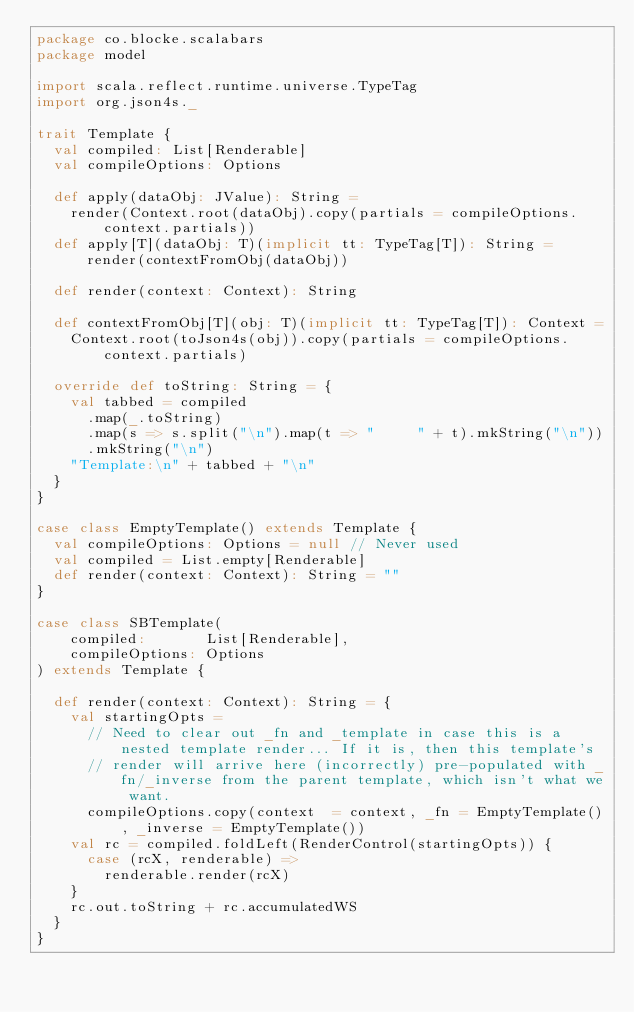<code> <loc_0><loc_0><loc_500><loc_500><_Scala_>package co.blocke.scalabars
package model

import scala.reflect.runtime.universe.TypeTag
import org.json4s._

trait Template {
  val compiled: List[Renderable]
  val compileOptions: Options

  def apply(dataObj: JValue): String =
    render(Context.root(dataObj).copy(partials = compileOptions.context.partials))
  def apply[T](dataObj: T)(implicit tt: TypeTag[T]): String = render(contextFromObj(dataObj))

  def render(context: Context): String

  def contextFromObj[T](obj: T)(implicit tt: TypeTag[T]): Context =
    Context.root(toJson4s(obj)).copy(partials = compileOptions.context.partials)

  override def toString: String = {
    val tabbed = compiled
      .map(_.toString)
      .map(s => s.split("\n").map(t => "     " + t).mkString("\n"))
      .mkString("\n")
    "Template:\n" + tabbed + "\n"
  }
}

case class EmptyTemplate() extends Template {
  val compileOptions: Options = null // Never used
  val compiled = List.empty[Renderable]
  def render(context: Context): String = ""
}

case class SBTemplate(
    compiled:       List[Renderable],
    compileOptions: Options
) extends Template {

  def render(context: Context): String = {
    val startingOpts =
      // Need to clear out _fn and _template in case this is a nested template render... If it is, then this template's
      // render will arrive here (incorrectly) pre-populated with _fn/_inverse from the parent template, which isn't what we want.
      compileOptions.copy(context  = context, _fn = EmptyTemplate(), _inverse = EmptyTemplate())
    val rc = compiled.foldLeft(RenderControl(startingOpts)) {
      case (rcX, renderable) =>
        renderable.render(rcX)
    }
    rc.out.toString + rc.accumulatedWS
  }
}
</code> 